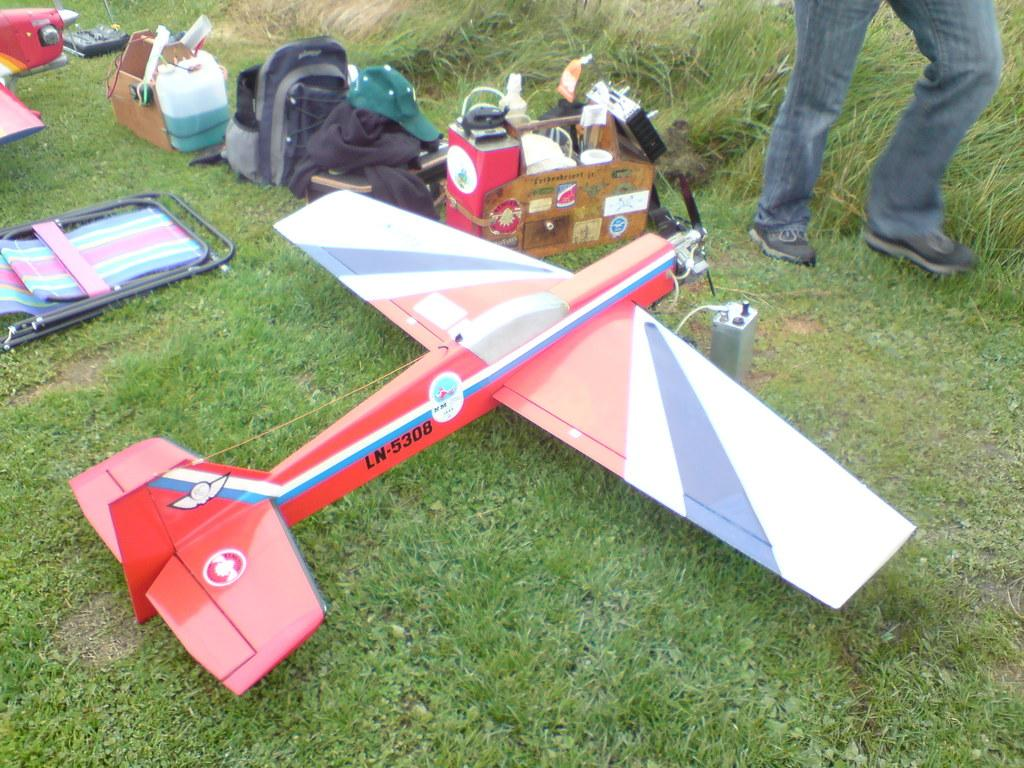<image>
Write a terse but informative summary of the picture. A red colored remote plane  which named as LN-5308 is  placed in a land 